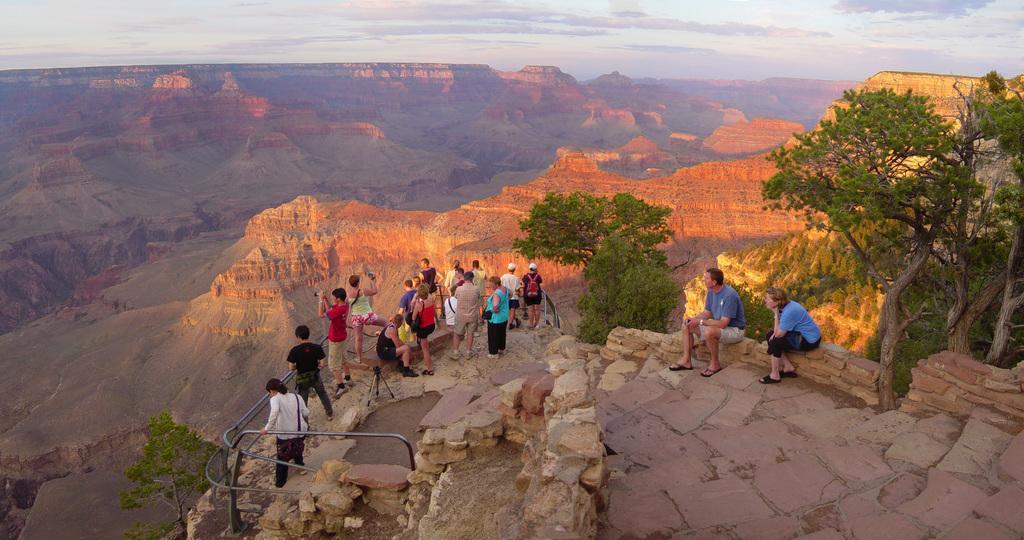Describe this image in one or two sentences. In this image there are people standing on a mountain and few are sitting, in the background there are mountains, trees and the sky. 